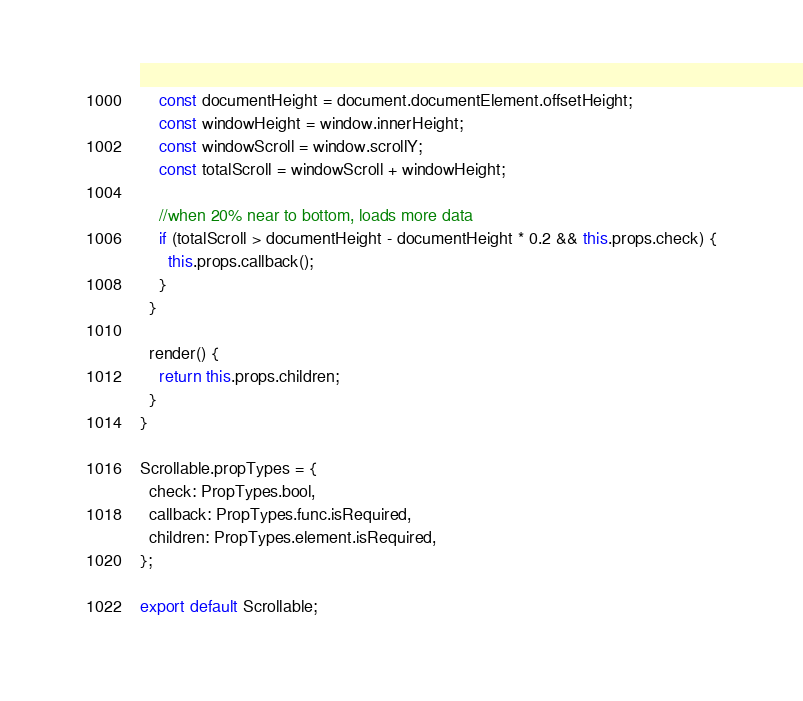<code> <loc_0><loc_0><loc_500><loc_500><_JavaScript_>    const documentHeight = document.documentElement.offsetHeight;
    const windowHeight = window.innerHeight;
    const windowScroll = window.scrollY;
    const totalScroll = windowScroll + windowHeight;

    //when 20% near to bottom, loads more data
    if (totalScroll > documentHeight - documentHeight * 0.2 && this.props.check) {
      this.props.callback();
    }
  }

  render() {
    return this.props.children;
  }
}

Scrollable.propTypes = {
  check: PropTypes.bool,
  callback: PropTypes.func.isRequired,
  children: PropTypes.element.isRequired,
};

export default Scrollable;
</code> 